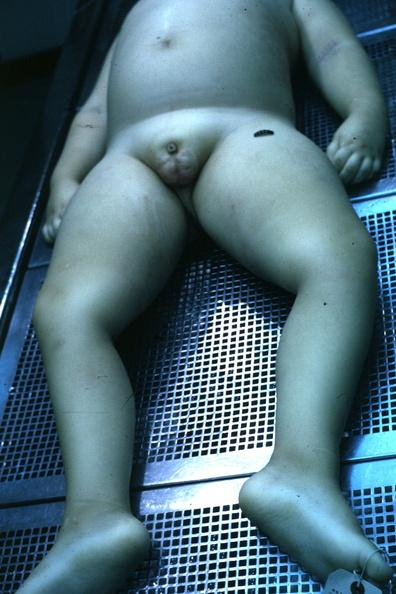what is present?
Answer the question using a single word or phrase. Underdevelopment 